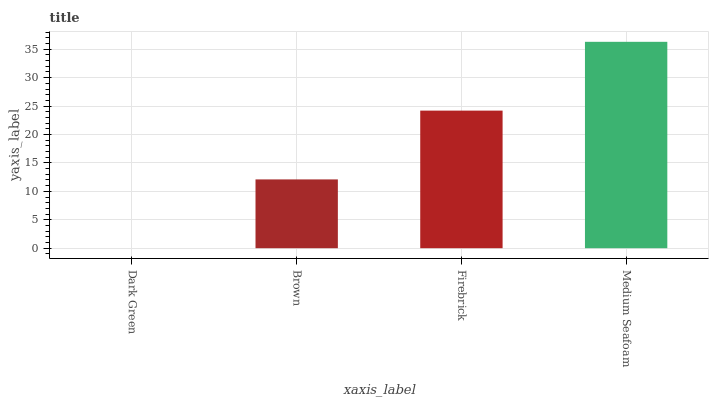Is Dark Green the minimum?
Answer yes or no. Yes. Is Medium Seafoam the maximum?
Answer yes or no. Yes. Is Brown the minimum?
Answer yes or no. No. Is Brown the maximum?
Answer yes or no. No. Is Brown greater than Dark Green?
Answer yes or no. Yes. Is Dark Green less than Brown?
Answer yes or no. Yes. Is Dark Green greater than Brown?
Answer yes or no. No. Is Brown less than Dark Green?
Answer yes or no. No. Is Firebrick the high median?
Answer yes or no. Yes. Is Brown the low median?
Answer yes or no. Yes. Is Brown the high median?
Answer yes or no. No. Is Medium Seafoam the low median?
Answer yes or no. No. 